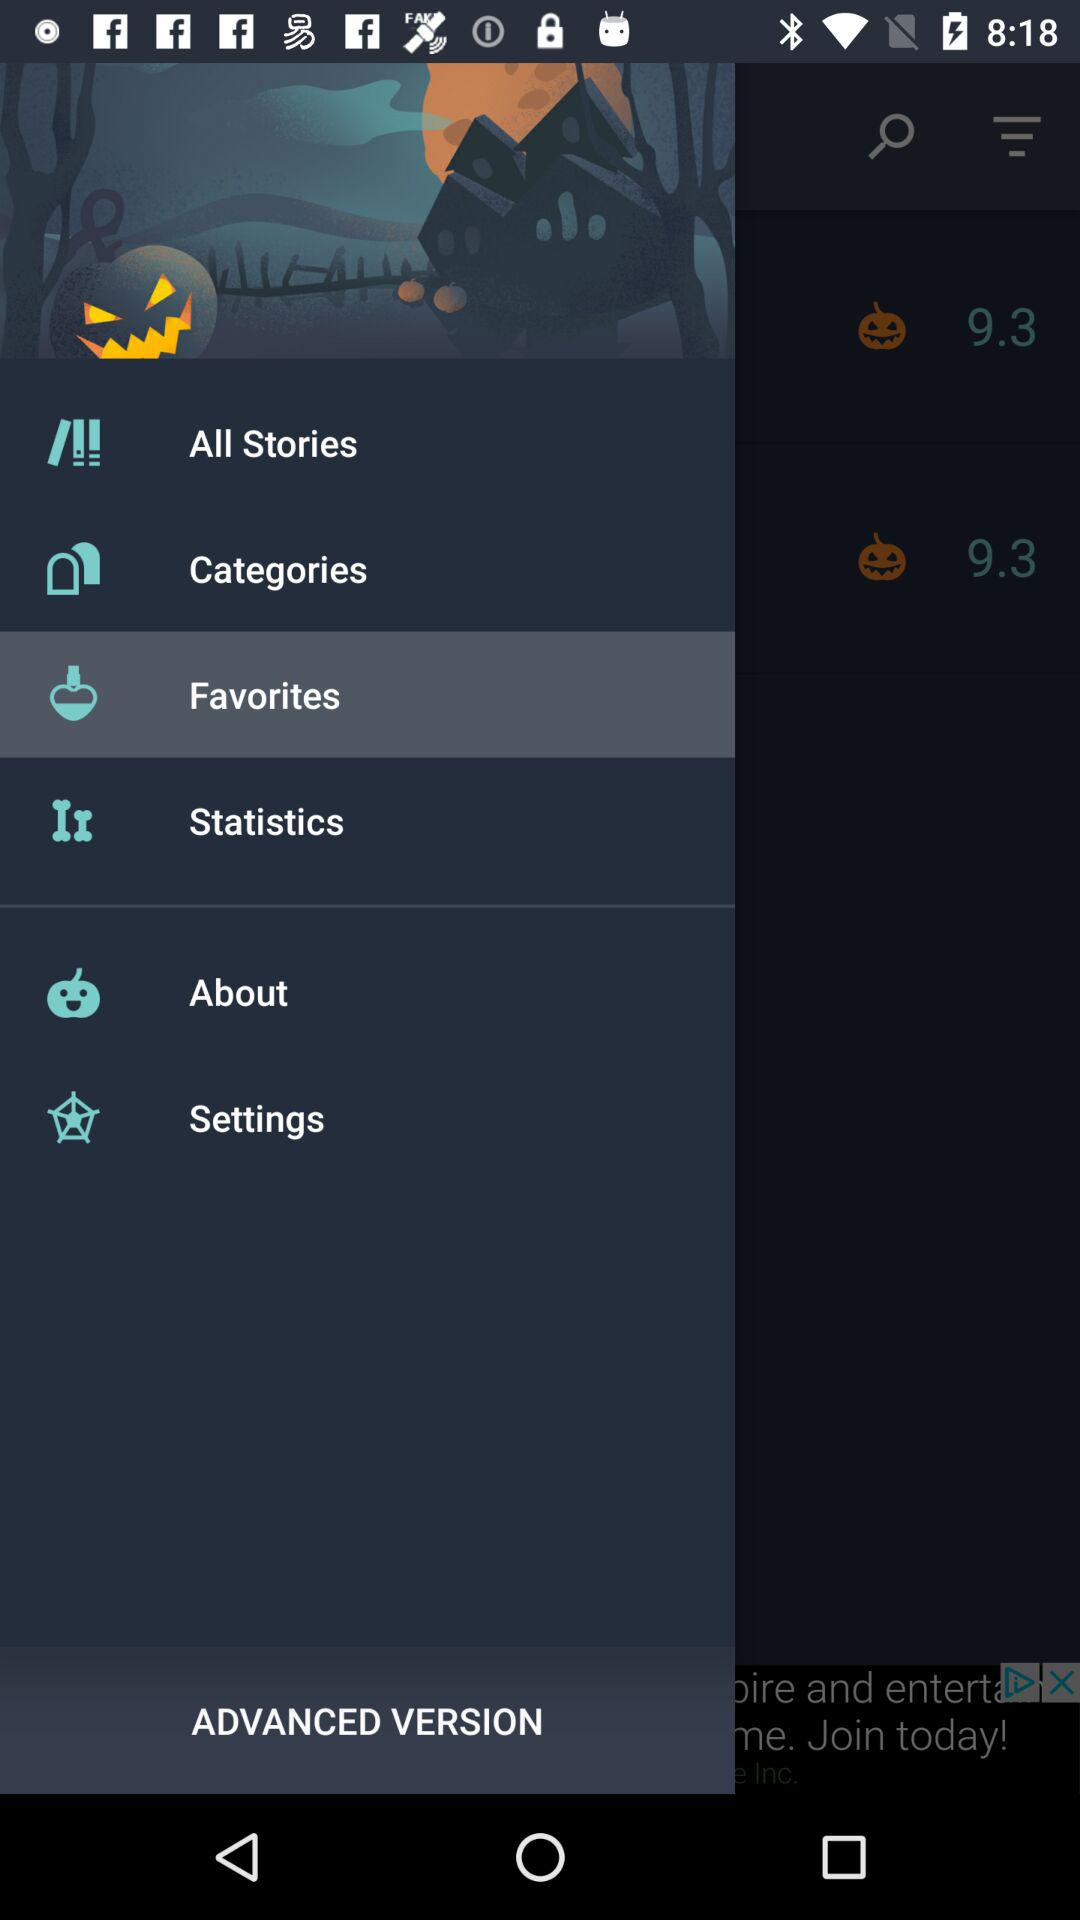Which item has been selected? The selected item is "Favorites". 